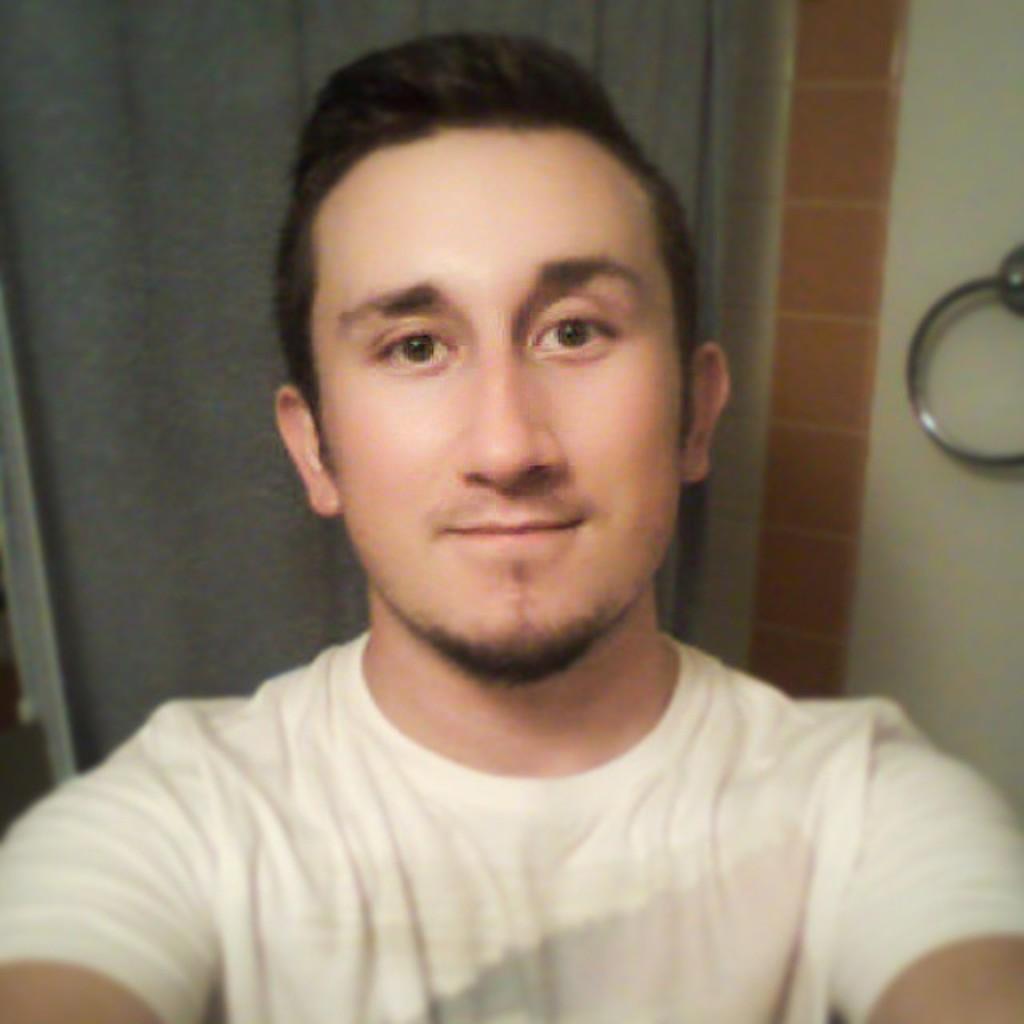Can you describe this image briefly? In this image, I can see the man smiling. He wore a white T-shirt. This looks like a hanger, which is attached to the wall. I think this is the curtain hanging. 